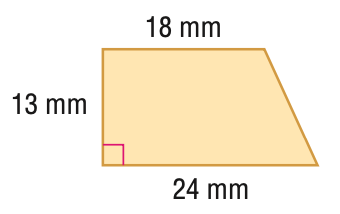Answer the mathemtical geometry problem and directly provide the correct option letter.
Question: Find the area of the trapezoid.
Choices: A: 234 B: 273 C: 286 D: 312 B 